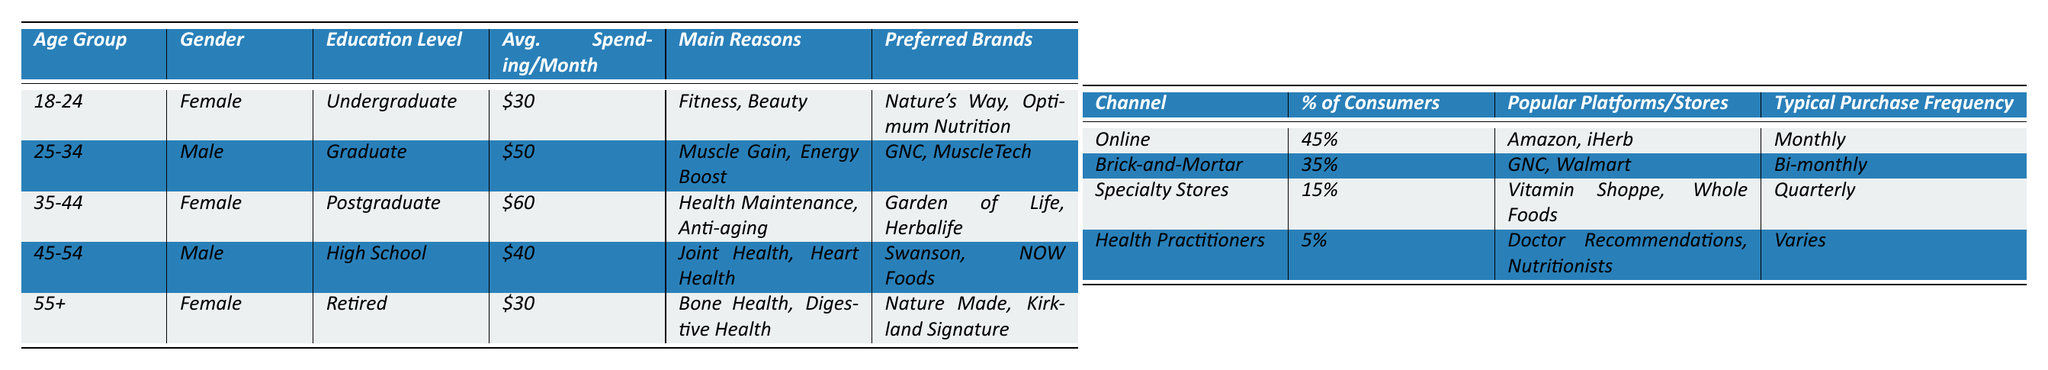What is the average spending per month for the age group 35-44? The average spending per month for the age group 35-44 is provided in the table as $60.
Answer: $60 How many percentage of consumers purchase dietary supplements online? The table indicates that 45% of consumers purchase dietary supplements online.
Answer: 45% Which age group has the highest average spending per month? The age group 35-44 has the highest average spending per month of $60 compared to other age groups listed in the table.
Answer: 35-44 What are the preferred brands for the 18-24 age group? According to the table, the preferred brands for the 18-24 age group are Nature's Way and Optimum Nutrition.
Answer: Nature's Way, Optimum Nutrition Is the preferred brand for the 45-54 age group MuscleTech? Referring to the table, the preferred brands for the 45-54 age group are Swanson and NOW Foods, not MuscleTech.
Answer: No What is the typical purchase frequency for consumers in specialty stores? The table states that the typical purchase frequency for consumers in specialty stores is quarterly.
Answer: Quarterly Which demographic has the lowest average spending per month? The demographics 18-24 and 55+ both have the same average spending per month of $30, which is the lowest among all listed groups.
Answer: 18-24, 55+ Calculate the total average spending per month for males in the age groups listed. For males in the listed age groups (25-34 and 45-54), the average spendings are $50 and $40 respectively. Their total average spending is (50 + 40) / 2 = $45.
Answer: $45 What percentage of consumers prefer purchasing supplements from health practitioners? The table shows that 5% of consumers prefer purchasing dietary supplements from health practitioners.
Answer: 5% Does the age group 55+ purchase supplements mainly for beauty reasons? The main reasons for purchase for the age group 55+ are Bone Health and Digestive Health as indicated in the table, not beauty.
Answer: No What is the most popular platform for purchasing supplements online? The popular platforms for online purchases listed in the table are Amazon and iHerb, therefore, one of them is the most popular.
Answer: Amazon, iHerb If a consumer spends $50 per month, which age group do they belong to? The age group 25-34 has an average spending of $50 per month, according to the table.
Answer: 25-34 Among the age groups listed, which has the highest focus on health maintenance? The age group 35-44 focuses on health maintenance, as indicated by the main reasons for purchase in the table.
Answer: 35-44 What are the preferred brands for consumers aged 55 and older? The preferred brands for consumers aged 55 and older, according to the table, are Nature Made and Kirkland Signature.
Answer: Nature Made, Kirkland Signature 